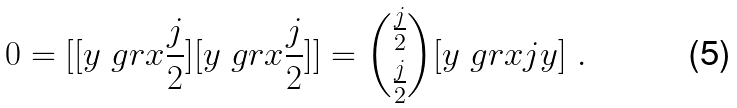Convert formula to latex. <formula><loc_0><loc_0><loc_500><loc_500>0 = [ [ y \ g r { x } { \frac { j } { 2 } } ] [ y \ g r { x } { \frac { j } { 2 } } ] ] = { \binom { \frac { j } { 2 } } { \frac { j } { 2 } } } [ y \ g r { x } { j } y ] \ .</formula> 